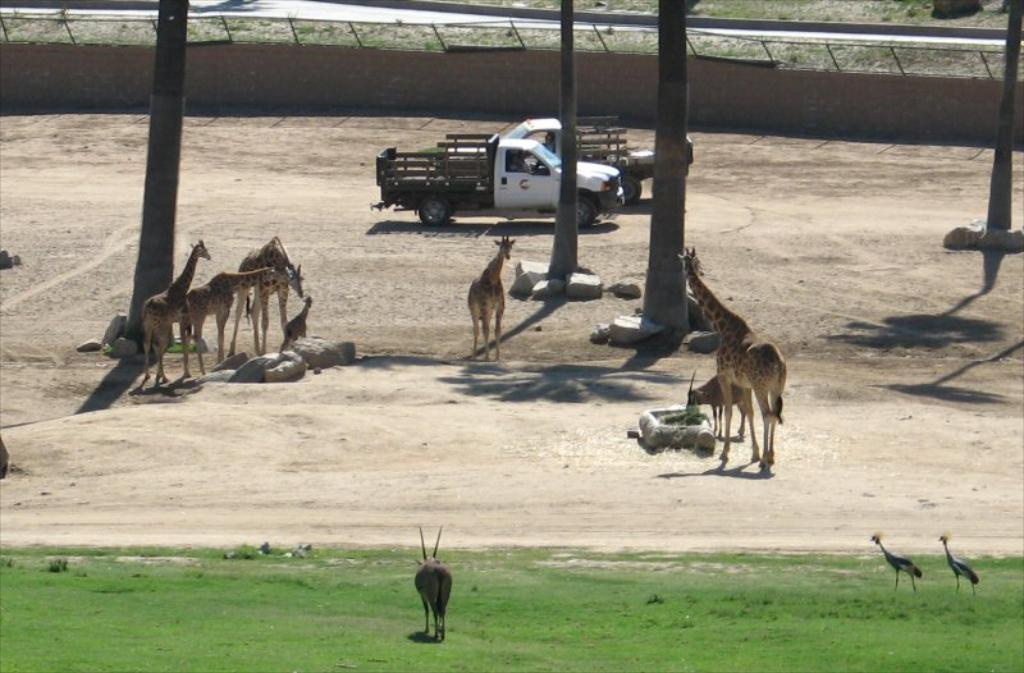What type of animals are in the center of the image? There are animals in the center of the image, but the specific type cannot be determined from the provided facts. What can be seen on the right side of the image? There are birds on the right side of the image. What is at the bottom of the image? There is grass at the bottom of the image. What is visible in the background of the image? There are trees, vehicles, and a wall in the background of the image. Reasoning: Let' Let's think step by step in order to produce the conversation. We start by identifying the main subjects and objects in the image based on the provided facts. We then formulate questions that focus on the location and characteristics of these subjects and objects, ensuring that each question can be answered definitively with the information given. We avoid yes/no questions and ensure that the language is simple and clear. Absurd Question/Answer: How many eggs are hanging from the cobweb in the image? There is no cobweb or eggs present in the image. What type of money can be seen in the image? There is no money present in the image. 